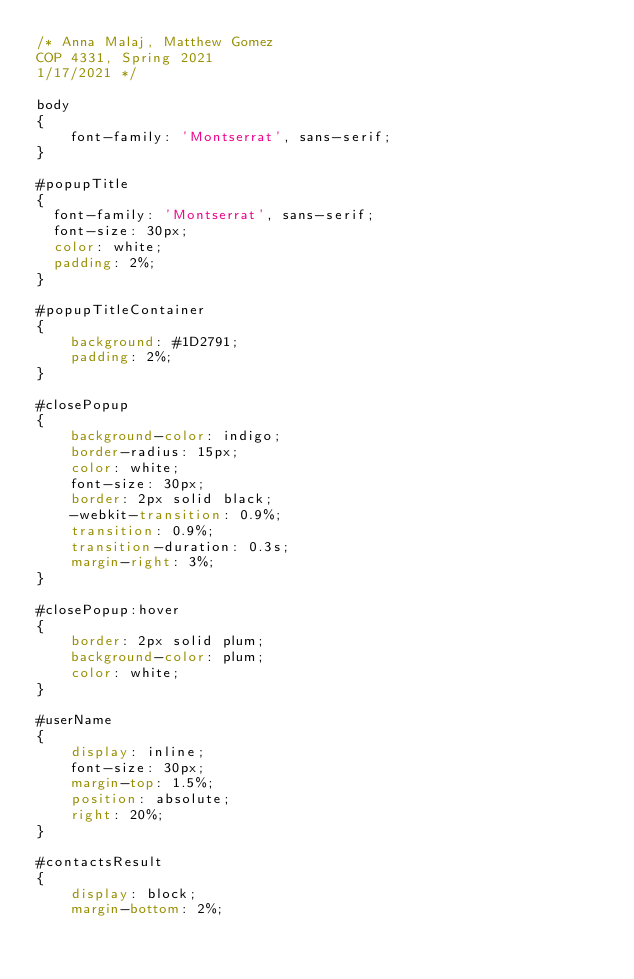Convert code to text. <code><loc_0><loc_0><loc_500><loc_500><_CSS_>/* Anna Malaj, Matthew Gomez
COP 4331, Spring 2021
1/17/2021 */

body
{
    font-family: 'Montserrat', sans-serif;
}

#popupTitle
{
  font-family: 'Montserrat', sans-serif;
  font-size: 30px;
  color: white;
  padding: 2%;
}

#popupTitleContainer
{
    background: #1D2791;
    padding: 2%;
}

#closePopup
{
    background-color: indigo;
    border-radius: 15px;
    color: white;
    font-size: 30px;
    border: 2px solid black;
    -webkit-transition: 0.9%;
    transition: 0.9%;
    transition-duration: 0.3s;
    margin-right: 3%;
}

#closePopup:hover
{
    border: 2px solid plum;
    background-color: plum;
    color: white;
}

#userName
{
    display: inline;
    font-size: 30px;
    margin-top: 1.5%;
    position: absolute;
    right: 20%;
}

#contactsResult
{
    display: block;
    margin-bottom: 2%;</code> 